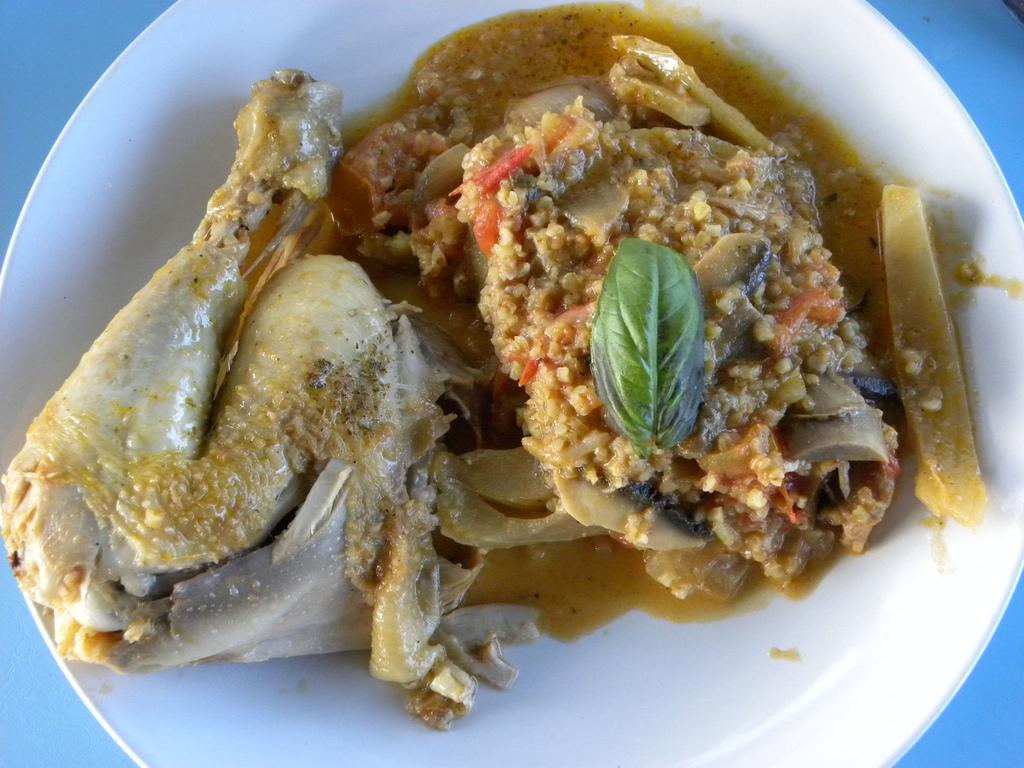What type of items can be seen in the image? There are eatable things in the image. How are the eatable items arranged in the image? The food is placed on a white plate. What color is the background of the image? The background of the image is blue. What type of bike is being discussed in the meeting in the image? There is no bike or meeting present in the image; it only features eatable items on a white plate with a blue background. 